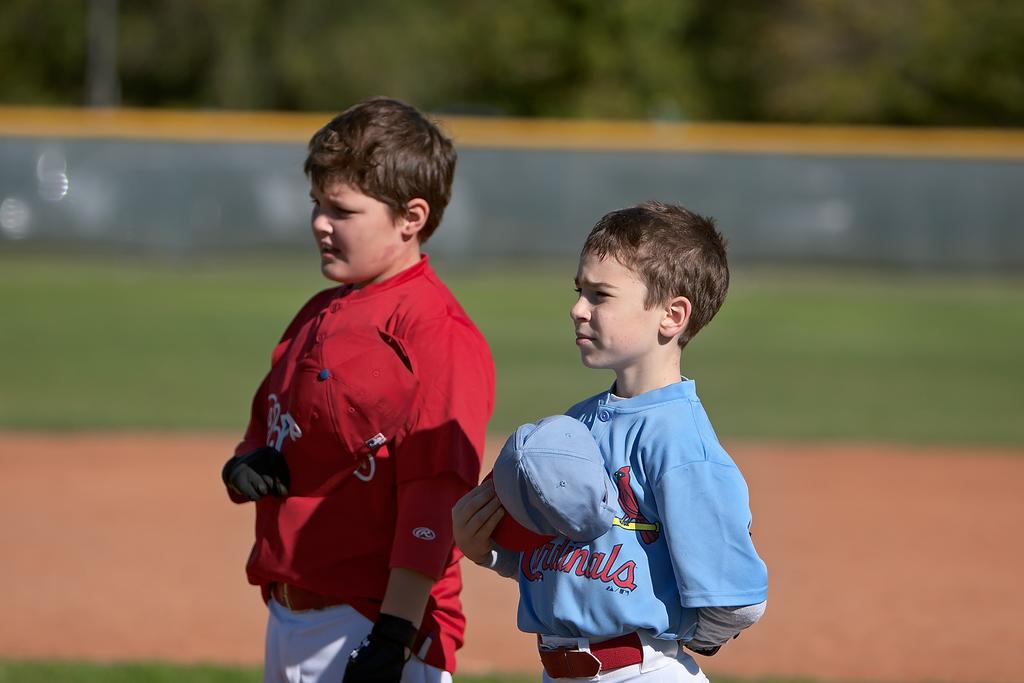<image>
Offer a succinct explanation of the picture presented. Youth ball players standing with their caps over their heart and Cardinals printed on the front in red. 